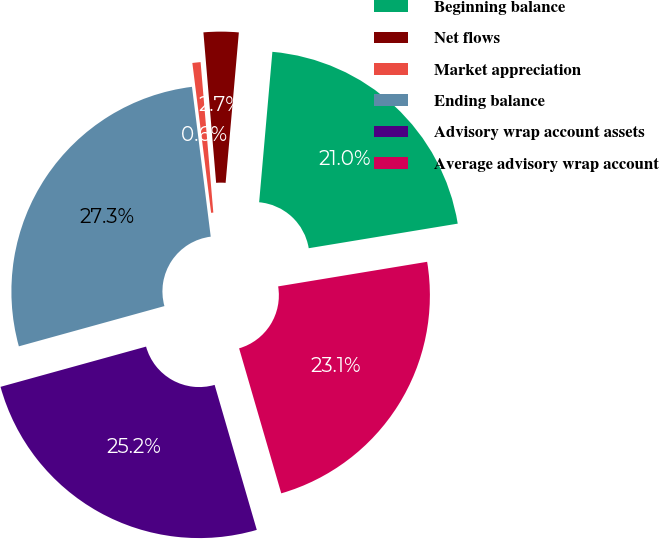<chart> <loc_0><loc_0><loc_500><loc_500><pie_chart><fcel>Beginning balance<fcel>Net flows<fcel>Market appreciation<fcel>Ending balance<fcel>Advisory wrap account assets<fcel>Average advisory wrap account<nl><fcel>21.0%<fcel>2.74%<fcel>0.64%<fcel>27.31%<fcel>25.21%<fcel>23.1%<nl></chart> 